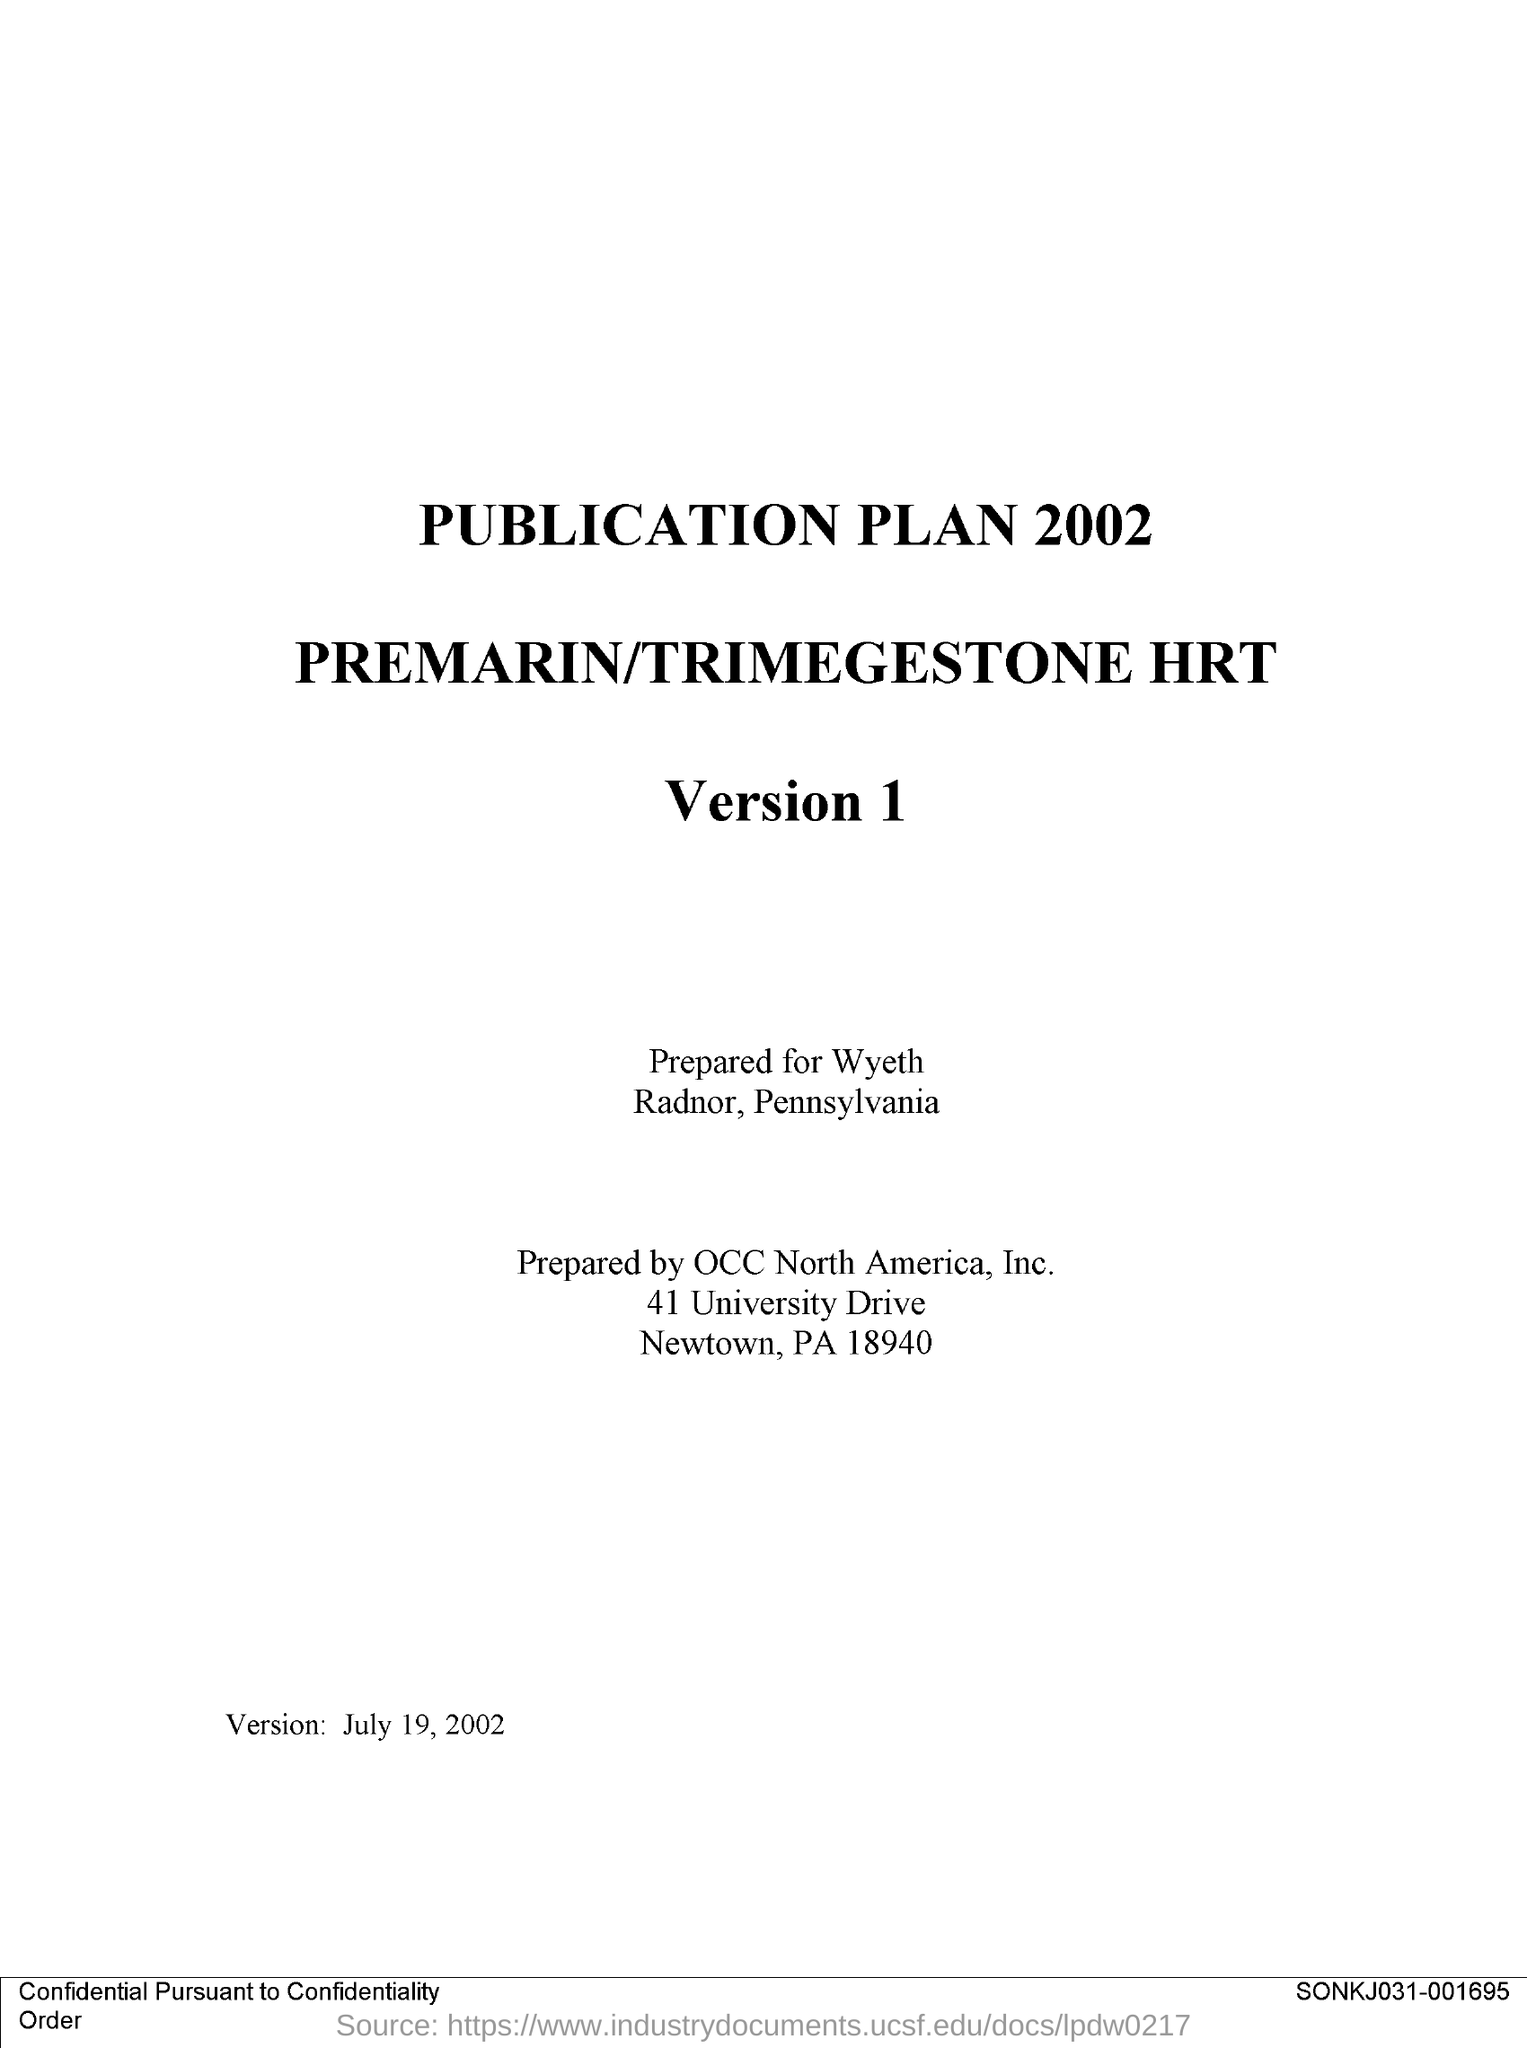Point out several critical features in this image. The first title in the document is 'Publication Plan 2002'. 